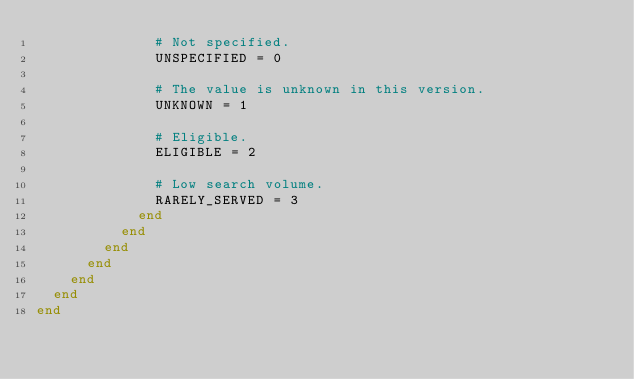<code> <loc_0><loc_0><loc_500><loc_500><_Ruby_>              # Not specified.
              UNSPECIFIED = 0

              # The value is unknown in this version.
              UNKNOWN = 1

              # Eligible.
              ELIGIBLE = 2

              # Low search volume.
              RARELY_SERVED = 3
            end
          end
        end
      end
    end
  end
end
</code> 